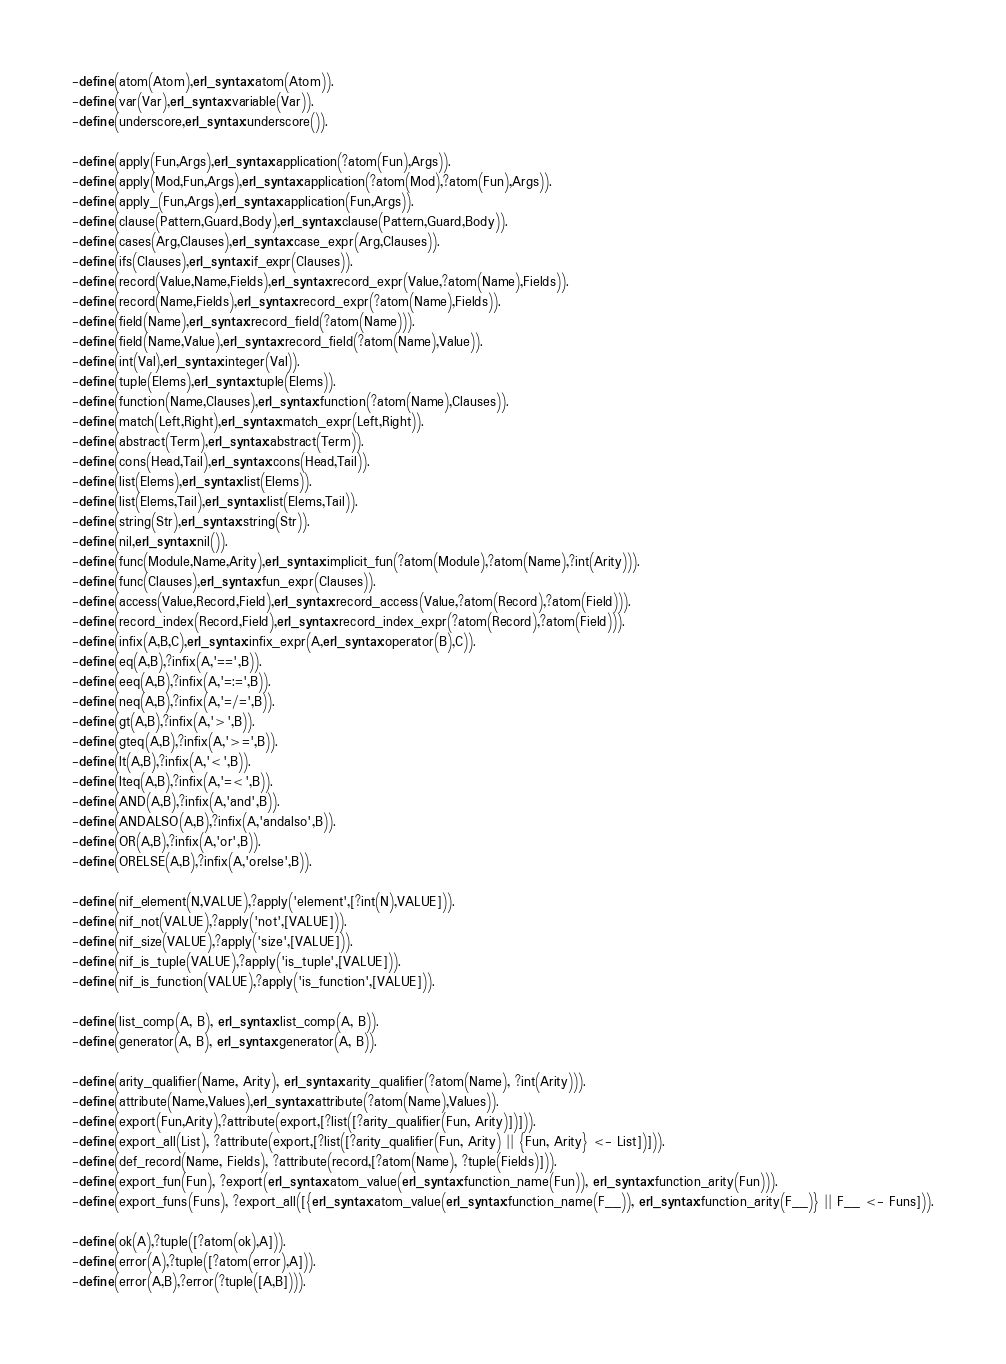<code> <loc_0><loc_0><loc_500><loc_500><_Erlang_>-define(atom(Atom),erl_syntax:atom(Atom)).
-define(var(Var),erl_syntax:variable(Var)).
-define(underscore,erl_syntax:underscore()).

-define(apply(Fun,Args),erl_syntax:application(?atom(Fun),Args)).
-define(apply(Mod,Fun,Args),erl_syntax:application(?atom(Mod),?atom(Fun),Args)).
-define(apply_(Fun,Args),erl_syntax:application(Fun,Args)).
-define(clause(Pattern,Guard,Body),erl_syntax:clause(Pattern,Guard,Body)).
-define(cases(Arg,Clauses),erl_syntax:case_expr(Arg,Clauses)).
-define(ifs(Clauses),erl_syntax:if_expr(Clauses)).
-define(record(Value,Name,Fields),erl_syntax:record_expr(Value,?atom(Name),Fields)).
-define(record(Name,Fields),erl_syntax:record_expr(?atom(Name),Fields)).
-define(field(Name),erl_syntax:record_field(?atom(Name))).
-define(field(Name,Value),erl_syntax:record_field(?atom(Name),Value)).
-define(int(Val),erl_syntax:integer(Val)).
-define(tuple(Elems),erl_syntax:tuple(Elems)).
-define(function(Name,Clauses),erl_syntax:function(?atom(Name),Clauses)).
-define(match(Left,Right),erl_syntax:match_expr(Left,Right)).
-define(abstract(Term),erl_syntax:abstract(Term)).
-define(cons(Head,Tail),erl_syntax:cons(Head,Tail)).
-define(list(Elems),erl_syntax:list(Elems)).
-define(list(Elems,Tail),erl_syntax:list(Elems,Tail)).
-define(string(Str),erl_syntax:string(Str)).
-define(nil,erl_syntax:nil()).
-define(func(Module,Name,Arity),erl_syntax:implicit_fun(?atom(Module),?atom(Name),?int(Arity))).
-define(func(Clauses),erl_syntax:fun_expr(Clauses)).
-define(access(Value,Record,Field),erl_syntax:record_access(Value,?atom(Record),?atom(Field))).
-define(record_index(Record,Field),erl_syntax:record_index_expr(?atom(Record),?atom(Field))).
-define(infix(A,B,C),erl_syntax:infix_expr(A,erl_syntax:operator(B),C)).
-define(eq(A,B),?infix(A,'==',B)).
-define(eeq(A,B),?infix(A,'=:=',B)).
-define(neq(A,B),?infix(A,'=/=',B)).
-define(gt(A,B),?infix(A,'>',B)).
-define(gteq(A,B),?infix(A,'>=',B)).
-define(lt(A,B),?infix(A,'<',B)).
-define(lteq(A,B),?infix(A,'=<',B)).
-define(AND(A,B),?infix(A,'and',B)).
-define(ANDALSO(A,B),?infix(A,'andalso',B)).
-define(OR(A,B),?infix(A,'or',B)).
-define(ORELSE(A,B),?infix(A,'orelse',B)).

-define(nif_element(N,VALUE),?apply('element',[?int(N),VALUE])).
-define(nif_not(VALUE),?apply('not',[VALUE])).
-define(nif_size(VALUE),?apply('size',[VALUE])).
-define(nif_is_tuple(VALUE),?apply('is_tuple',[VALUE])).
-define(nif_is_function(VALUE),?apply('is_function',[VALUE])).

-define(list_comp(A, B), erl_syntax:list_comp(A, B)).
-define(generator(A, B), erl_syntax:generator(A, B)).

-define(arity_qualifier(Name, Arity), erl_syntax:arity_qualifier(?atom(Name), ?int(Arity))).
-define(attribute(Name,Values),erl_syntax:attribute(?atom(Name),Values)).
-define(export(Fun,Arity),?attribute(export,[?list([?arity_qualifier(Fun, Arity)])])).
-define(export_all(List), ?attribute(export,[?list([?arity_qualifier(Fun, Arity) || {Fun, Arity} <- List])])).
-define(def_record(Name, Fields), ?attribute(record,[?atom(Name), ?tuple(Fields)])).
-define(export_fun(Fun), ?export(erl_syntax:atom_value(erl_syntax:function_name(Fun)), erl_syntax:function_arity(Fun))).
-define(export_funs(Funs), ?export_all([{erl_syntax:atom_value(erl_syntax:function_name(F__)), erl_syntax:function_arity(F__)} || F__ <- Funs])).

-define(ok(A),?tuple([?atom(ok),A])).
-define(error(A),?tuple([?atom(error),A])).
-define(error(A,B),?error(?tuple([A,B]))).
</code> 